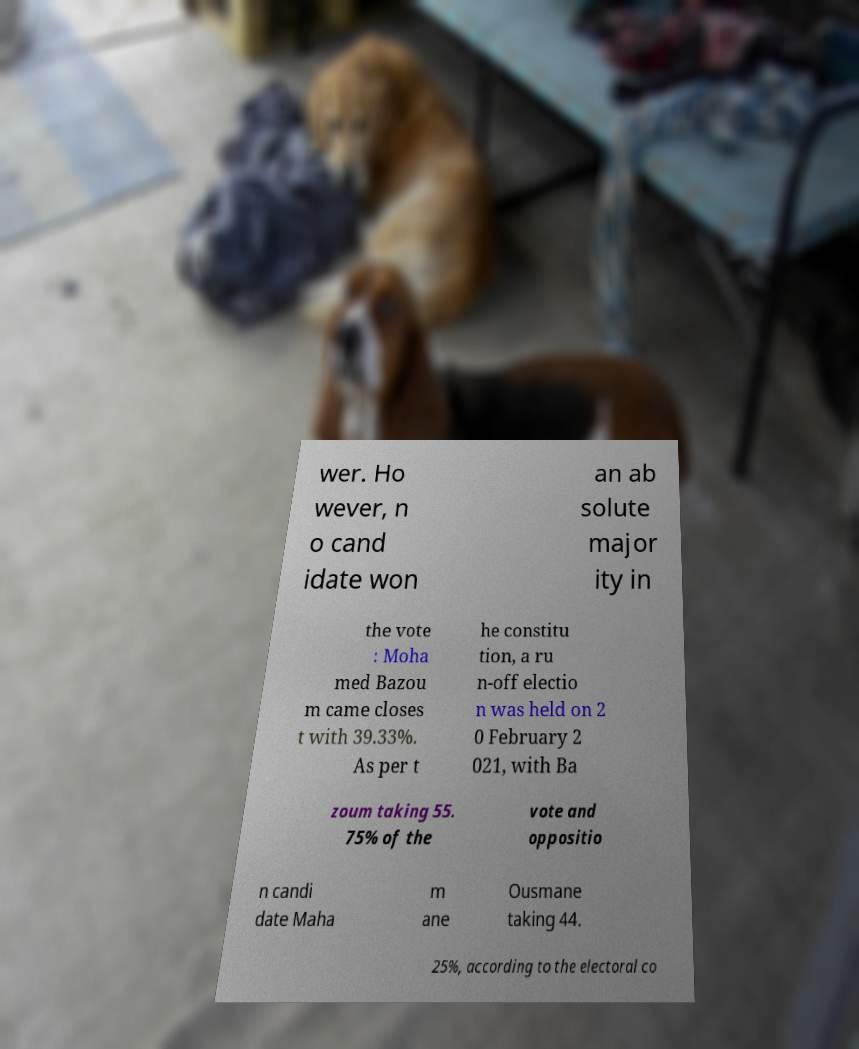I need the written content from this picture converted into text. Can you do that? wer. Ho wever, n o cand idate won an ab solute major ity in the vote : Moha med Bazou m came closes t with 39.33%. As per t he constitu tion, a ru n-off electio n was held on 2 0 February 2 021, with Ba zoum taking 55. 75% of the vote and oppositio n candi date Maha m ane Ousmane taking 44. 25%, according to the electoral co 